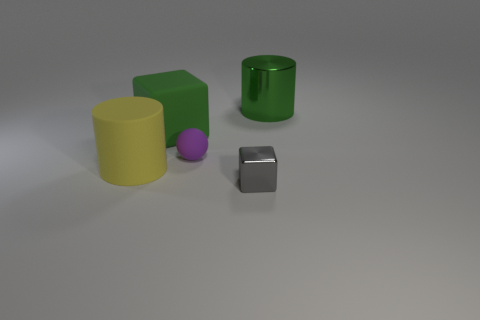There is a large cylinder that is the same material as the tiny gray block; what color is it?
Provide a succinct answer. Green. The big object that is the same color as the big matte cube is what shape?
Offer a terse response. Cylinder. Is the number of big green metallic cylinders behind the green matte thing the same as the number of tiny gray cubes that are to the left of the tiny matte object?
Offer a terse response. No. There is a object on the left side of the cube behind the yellow rubber cylinder; what is its shape?
Give a very brief answer. Cylinder. There is another big thing that is the same shape as the big yellow thing; what is it made of?
Offer a very short reply. Metal. There is a ball that is the same size as the gray metallic cube; what color is it?
Offer a terse response. Purple. Are there an equal number of big green blocks in front of the big yellow matte thing and big cyan rubber objects?
Your answer should be very brief. Yes. What is the color of the big rubber thing in front of the large green thing that is left of the small metal block?
Provide a short and direct response. Yellow. There is a green thing that is right of the tiny object to the left of the metal block; how big is it?
Provide a short and direct response. Large. There is a matte block that is the same color as the big shiny cylinder; what is its size?
Your answer should be very brief. Large. 